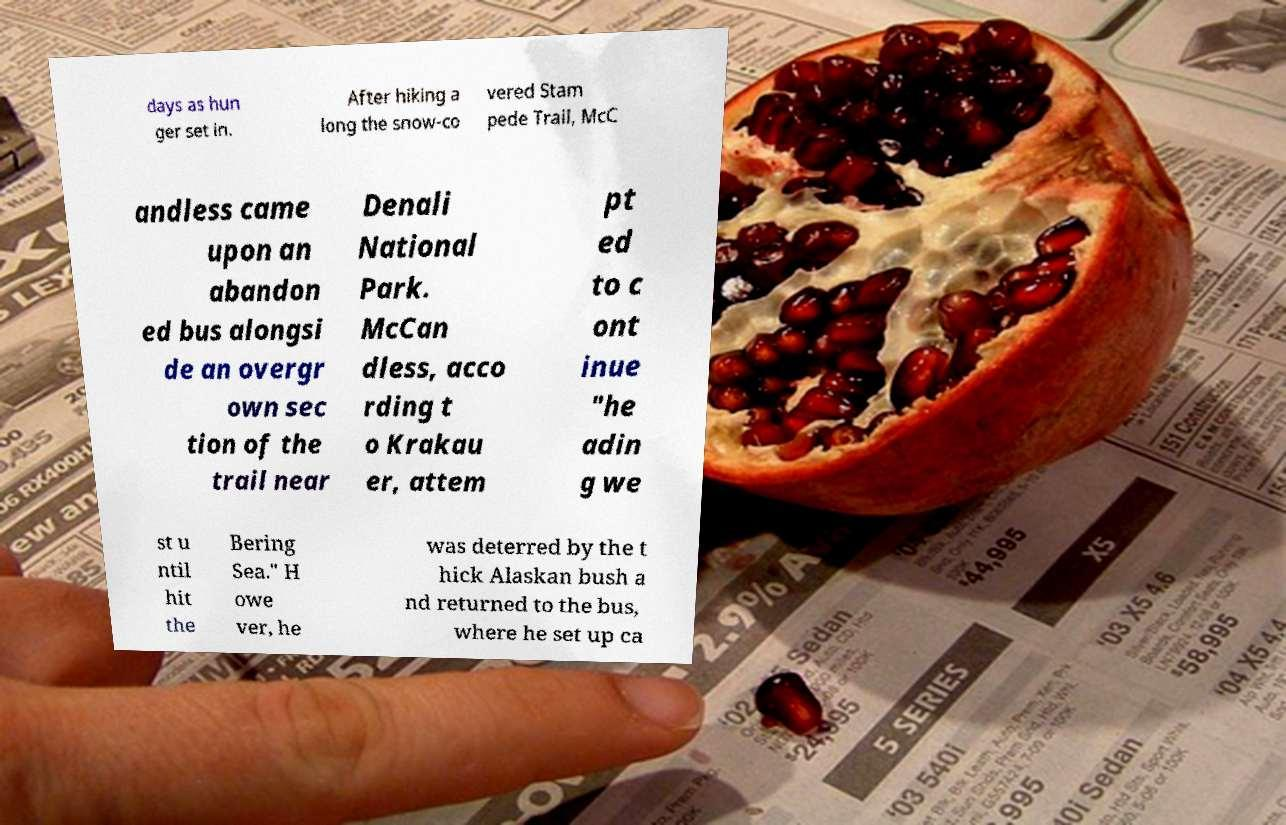What messages or text are displayed in this image? I need them in a readable, typed format. days as hun ger set in. After hiking a long the snow-co vered Stam pede Trail, McC andless came upon an abandon ed bus alongsi de an overgr own sec tion of the trail near Denali National Park. McCan dless, acco rding t o Krakau er, attem pt ed to c ont inue "he adin g we st u ntil hit the Bering Sea." H owe ver, he was deterred by the t hick Alaskan bush a nd returned to the bus, where he set up ca 